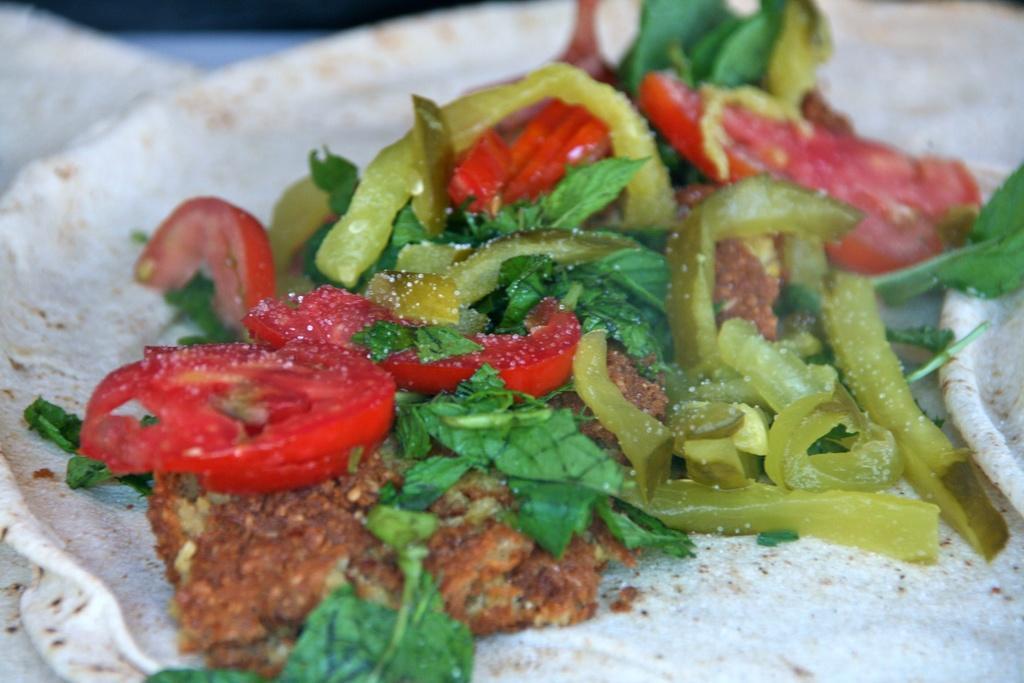In one or two sentences, can you explain what this image depicts? In this image there are few chapatis having few tomato slices, capsicum slices, leafy vegetables and some food are on it. 